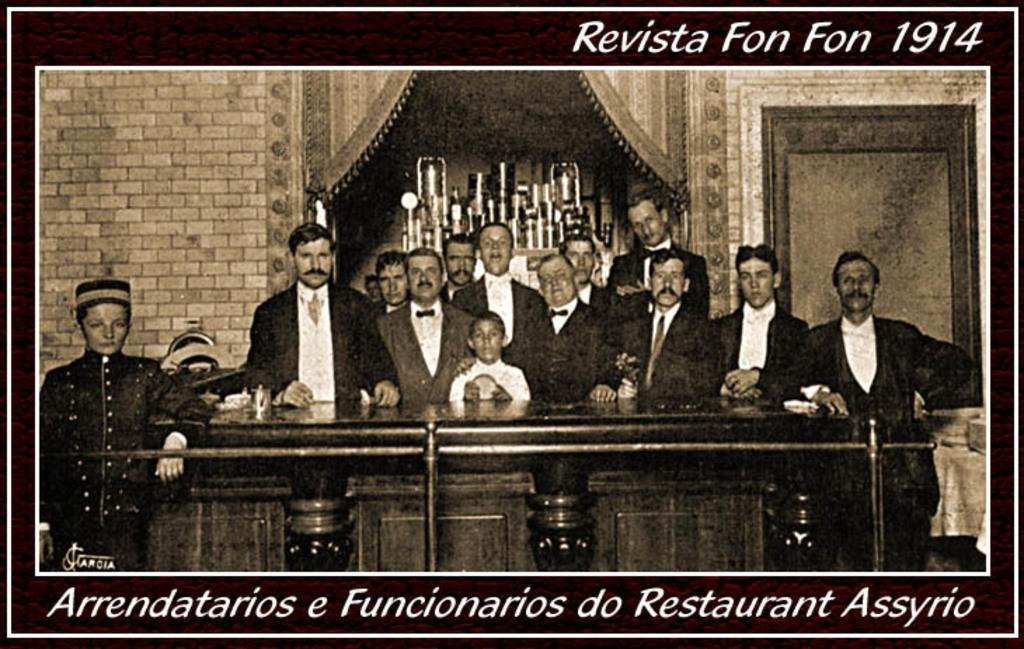What can be observed about the people in the image? There are people standing in the image, and they are wearing coats. Can you describe any specific clothing items worn by the people? One person is wearing a cap. What other objects or structures can be seen in the image? There are stands and rods in the image. Is there any text visible in the image? Yes, there is some text visible in the image. Reasoning: Let'g: Let's think step by step in order to produce the conversation. We start by identifying the main subjects in the image, which are the people. Then, we describe their clothing and any specific items they are wearing. Next, we expand the conversation to include other objects and structures present in the image, such as stands and rods. Finally, we mention the presence of text in the image. Absurd Question/Answer: Can you tell me what the tiger is doing in the image? There is no tiger present in the image. What role does the sister play in the image? There is no mention of a sister in the image. 